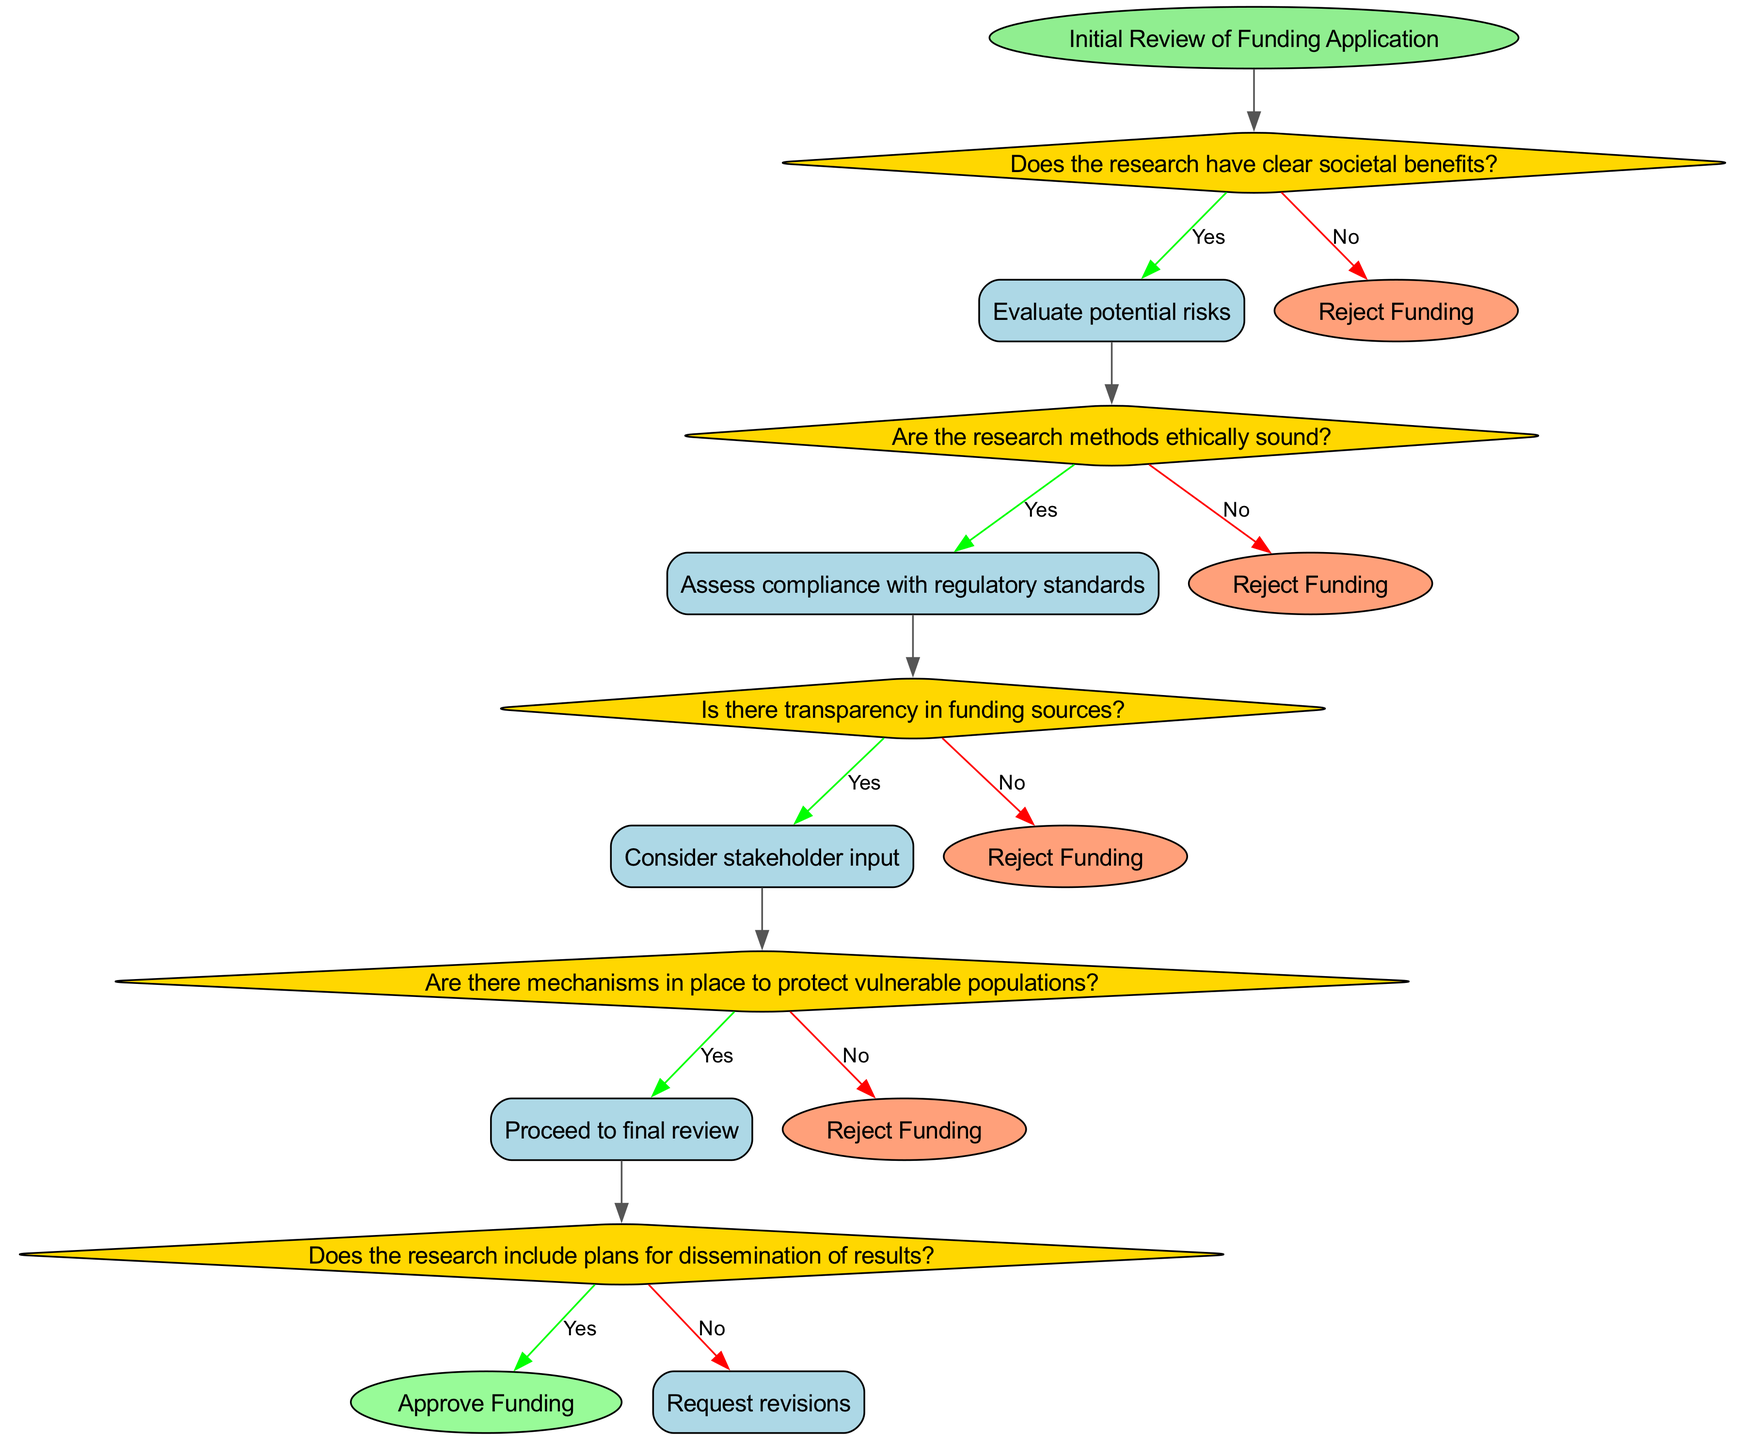What is the first question in the decision tree? The first question that arises in the decision tree is "Does the research have clear societal benefits?" as indicated by the first step branching from the initial review node.
Answer: Does the research have clear societal benefits? How many final outcomes are there in the decision tree? There are three final outcomes in the decision tree: "Approve Funding", "Reject Funding", and "Request revisions". These outcomes emerge from the branching of the decision paths at various steps.
Answer: Three If the answer is no to the first question, what is the following action? If the answer to the first question "Does the research have clear societal benefits?" is no, the action taken is to "Reject Funding" as stated in the decision tree branching.
Answer: Reject Funding What is the last step before approving funding? The last step before approving funding involves asking "Does the research include plans for dissemination of results?" which determines whether funding will be approved or if revisions are needed.
Answer: Does the research include plans for dissemination of results? Which step assesses compliance with regulatory standards? The step that assesses compliance with regulatory standards follows the question "Are the research methods ethically sound?" and is labeled as the step where evaluation occurs if the answer is yes.
Answer: Assess compliance with regulatory standards What action follows if there are mechanisms in place to protect vulnerable populations? If there are mechanisms in place to protect vulnerable populations, the action taken is to "Proceed to final review" as indicated in the decision tree after a positive answer to that question.
Answer: Proceed to final review How many questions must be answered before reaching a final outcome? In total, there are five questions that need to be answered before reaching a final outcome, as outlined in the decision tree, moving through each decision point sequentially.
Answer: Five What will happen if there is a lack of transparency in funding sources? If there is a lack of transparency in funding sources as per the relevant question, the funding will be rejected according to the decision tree outcome indicated at that point.
Answer: Reject Funding What happens to the funding application after the final review? After the final review, if the research includes plans for dissemination of results, a decision will be made to "Approve Funding" according to the last step in the flow chart.
Answer: Approve Funding 